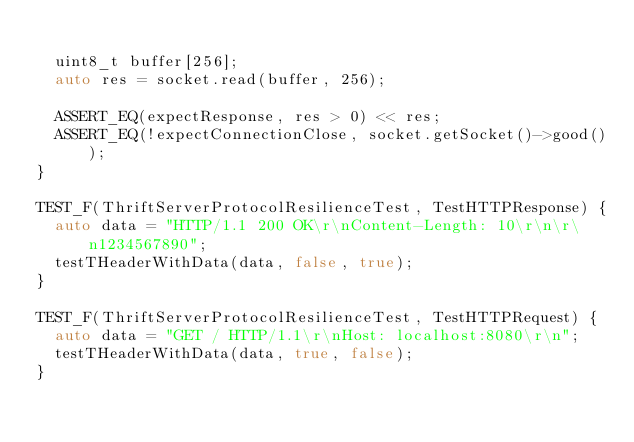Convert code to text. <code><loc_0><loc_0><loc_500><loc_500><_C++_>
  uint8_t buffer[256];
  auto res = socket.read(buffer, 256);

  ASSERT_EQ(expectResponse, res > 0) << res;
  ASSERT_EQ(!expectConnectionClose, socket.getSocket()->good());
}

TEST_F(ThriftServerProtocolResilienceTest, TestHTTPResponse) {
  auto data = "HTTP/1.1 200 OK\r\nContent-Length: 10\r\n\r\n1234567890";
  testTHeaderWithData(data, false, true);
}

TEST_F(ThriftServerProtocolResilienceTest, TestHTTPRequest) {
  auto data = "GET / HTTP/1.1\r\nHost: localhost:8080\r\n";
  testTHeaderWithData(data, true, false);
}
</code> 